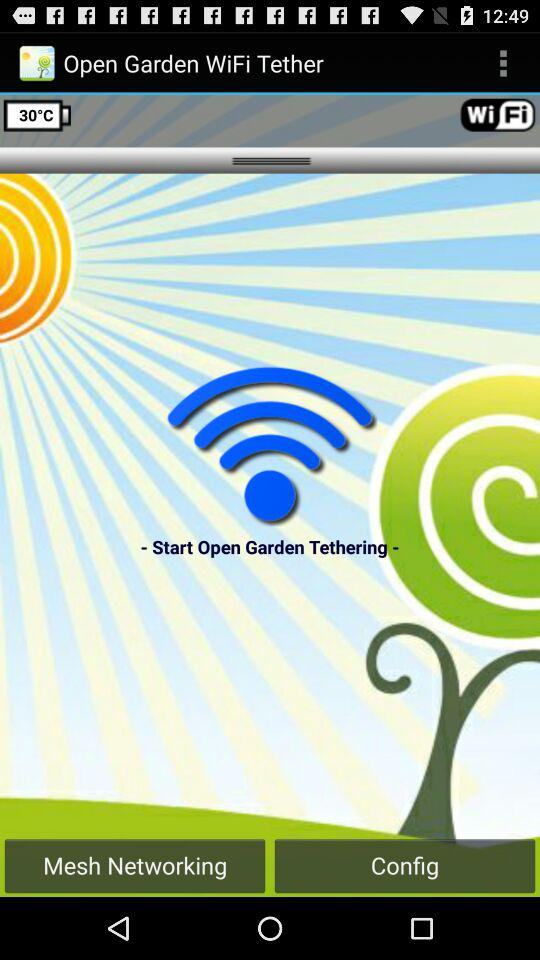What is the temperature? The temperature is 30 °C. 